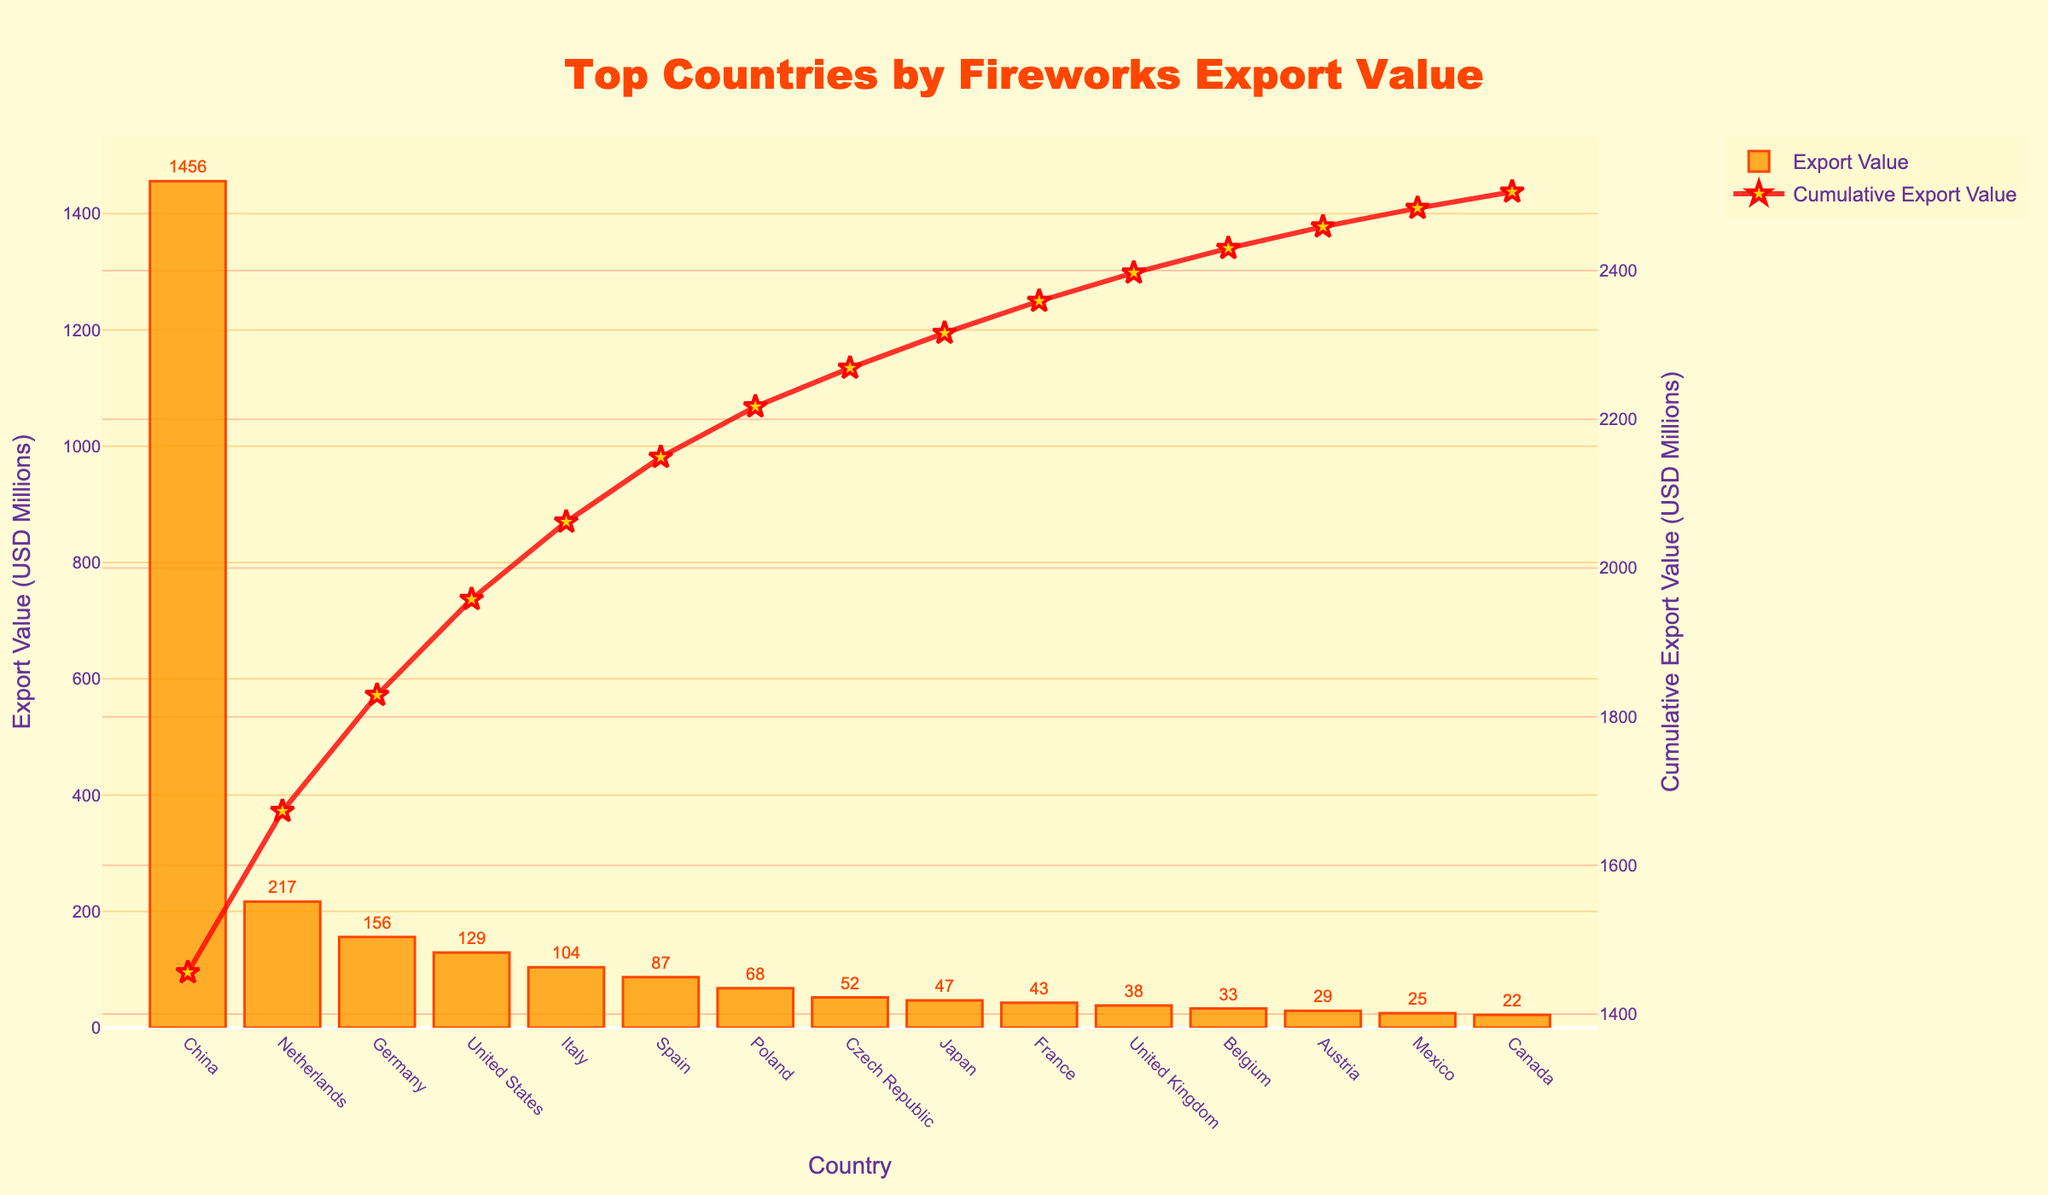Which country has the highest fireworks export value? By observing the bar heights and the text labels, it is clear that China has the highest fireworks export value, with 1456 USD millions.
Answer: China Which two countries have the second and third highest fireworks export values? By examining the heights of the bars and their labels, the Netherlands has the second highest export value with 217 USD millions, followed by Germany at 156 USD millions.
Answer: Netherlands and Germany What is the cumulative export value of the top 3 countries? By identifying the export values of China, Netherlands, and Germany (1456, 217, and 156 USD millions respectively) and summing them up: 1456 + 217 + 156 = 1829 USD millions.
Answer: 1829 How much more does China export compared to the United States in fireworks? By finding the difference between China's and the United States' export values: 1456 - 129 = 1327 USD millions.
Answer: 1327 What is the combined export value of Italy and Spain? By adding the export values of Italy and Spain: 104 + 87 = 191 USD millions.
Answer: 191 Among the top 10 countries listed, which country has the lowest fireworks export value? By comparing the bar lengths and identifying the smallest value among the top 10, France has the lowest export value within the top 10 with 43 USD millions.
Answer: France Which country ranks just below Japan in export value? By looking at the sequence of the bars from highest to lowest, France ranks just below Japan.
Answer: France How much is the cumulative export value right after adding Spain's value? By summing up the export values up to Spain: 1456 (China) + 217 (Netherlands) + 156 (Germany) + 129 (USA) + 104 (Italy) + 87 (Spain) = 2149 USD millions.
Answer: 2149 What is the average export value of the top 10 countries? By summing the export values of the top 10 countries and dividing by 10: (1456 + 217 + 156 + 129 + 104 + 87 + 68 + 52 + 47 + 43) / 10 = 2359 / 10 = 235.9 USD millions on average.
Answer: 235.9 What's the difference between the highest and lowest export values among the top 10 countries? By identifying the highest (China with 1456 USD millions) and lowest (France with 43 USD millions) and subtracting: 1456 - 43 = 1413 USD millions.
Answer: 1413 